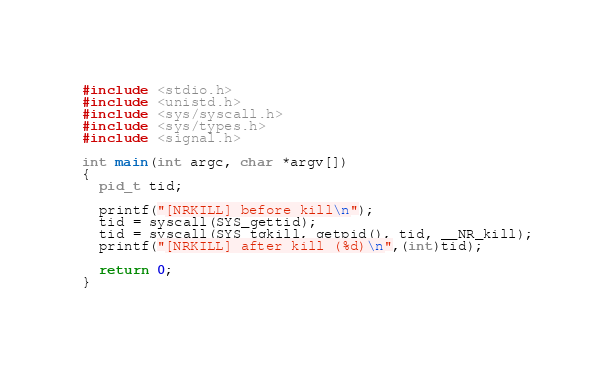Convert code to text. <code><loc_0><loc_0><loc_500><loc_500><_C_>#include <stdio.h>
#include <unistd.h>
#include <sys/syscall.h>
#include <sys/types.h>
#include <signal.h>

int main(int argc, char *argv[])
{
  pid_t tid;

  printf("[NRKILL] before kill\n");
  tid = syscall(SYS_gettid);
  tid = syscall(SYS_tgkill, getpid(), tid, __NR_kill);
  printf("[NRKILL] after kill (%d)\n",(int)tid);
  
  return 0;
}
</code> 